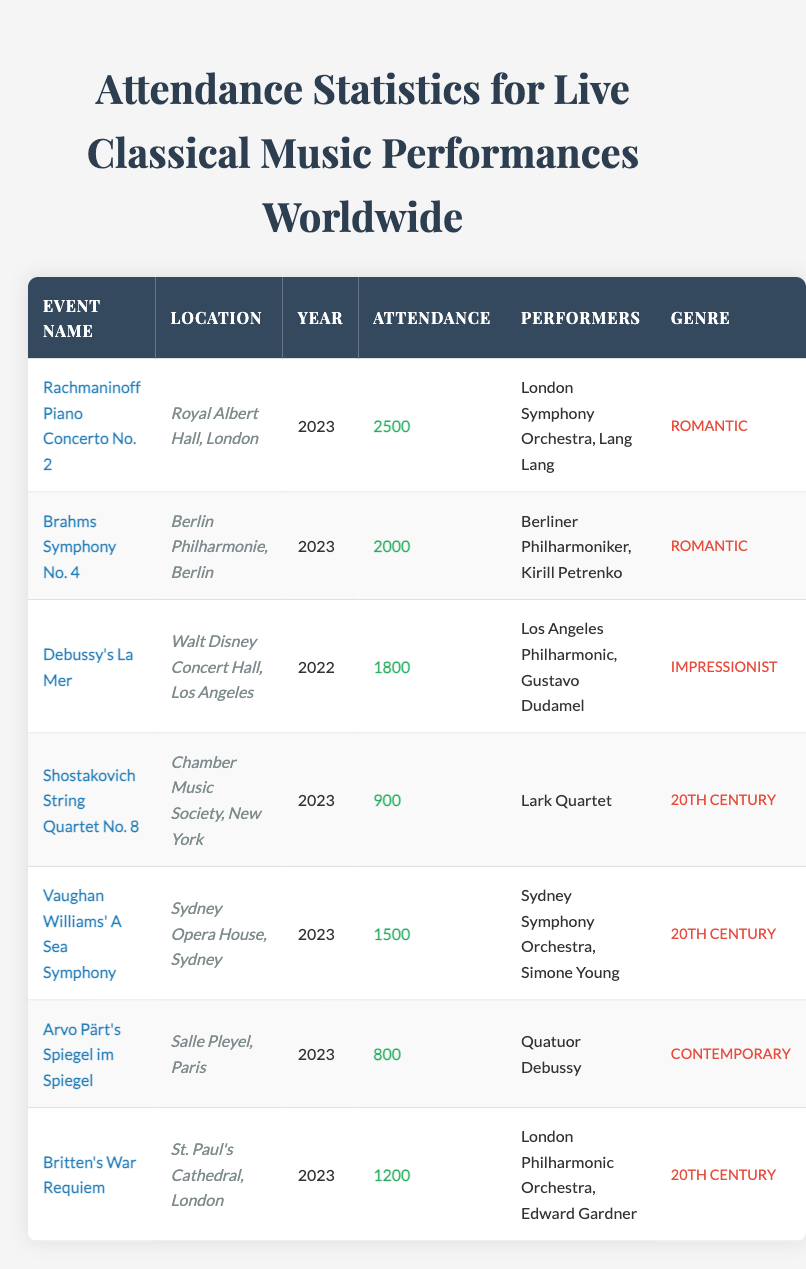What is the attendance for the Rachmaninoff Piano Concerto No. 2? The attendance for this event is given directly in the table under the "Attendance" column for that particular event. It shows the value of 2500.
Answer: 2500 How many performances had an attendance of 2000 or more? We look at each row in the attendance column: Rachmaninoff Piano Concerto No. 2 (2500), Brahms Symphony No. 4 (2000), and Debussy's La Mer (1800). Two events had an attendance equal to or greater than 2000.
Answer: 2 Is Vaughan Williams' A Sea Symphony performed in 2022? The event listing in the table shows that Vaughan Williams' A Sea Symphony took place in 2023, thus this statement is false.
Answer: No What is the total attendance for all events in 2023? Adding the attendance values for 2023 events: Rachmaninoff Piano Concerto No. 2 (2500), Brahms Symphony No. 4 (2000), Shostakovich String Quartet No. 8 (900), Vaughan Williams' A Sea Symphony (1500), Arvo Pärt's Spiegel im Spiegel (800), and Britten's War Requiem (1200) gives a total of 8100.
Answer: 8100 Which genre had the lowest attendance in 2023? Examining the attendance for each genre in 2023, Arvo Pärt's Spiegel im Spiegel in the Contemporary genre had the lowest attendance of 800.
Answer: Contemporary What is the average attendance across all listed performances? We first add the attendance numbers of all events: 2500 + 2000 + 1800 + 900 + 1500 + 800 + 1200 = 12000. Next, we divide this sum by the total number of performances, which is 7, giving an average of approximately 1714.
Answer: 1714 Did the London Symphony Orchestra perform any event in 2023? Observing the "Performers" column for 2023 events, we find that the London Symphony Orchestra performed in Rachmaninoff Piano Concerto No. 2 as well as Britten's War Requiem, confirming that they did perform in 2023.
Answer: Yes Which event had the highest attendance and what was the genre? The highest attendance shown in the table is for Rachmaninoff Piano Concerto No. 2 with 2500, and it falls under the Romantic genre.
Answer: Rachmaninoff Piano Concerto No. 2, Romantic 